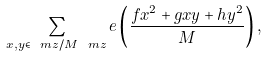Convert formula to latex. <formula><loc_0><loc_0><loc_500><loc_500>\sum _ { x , y \in \ m z / M \ m z } e \left ( \frac { f x ^ { 2 } + g x y + h y ^ { 2 } } { M } \right ) ,</formula> 